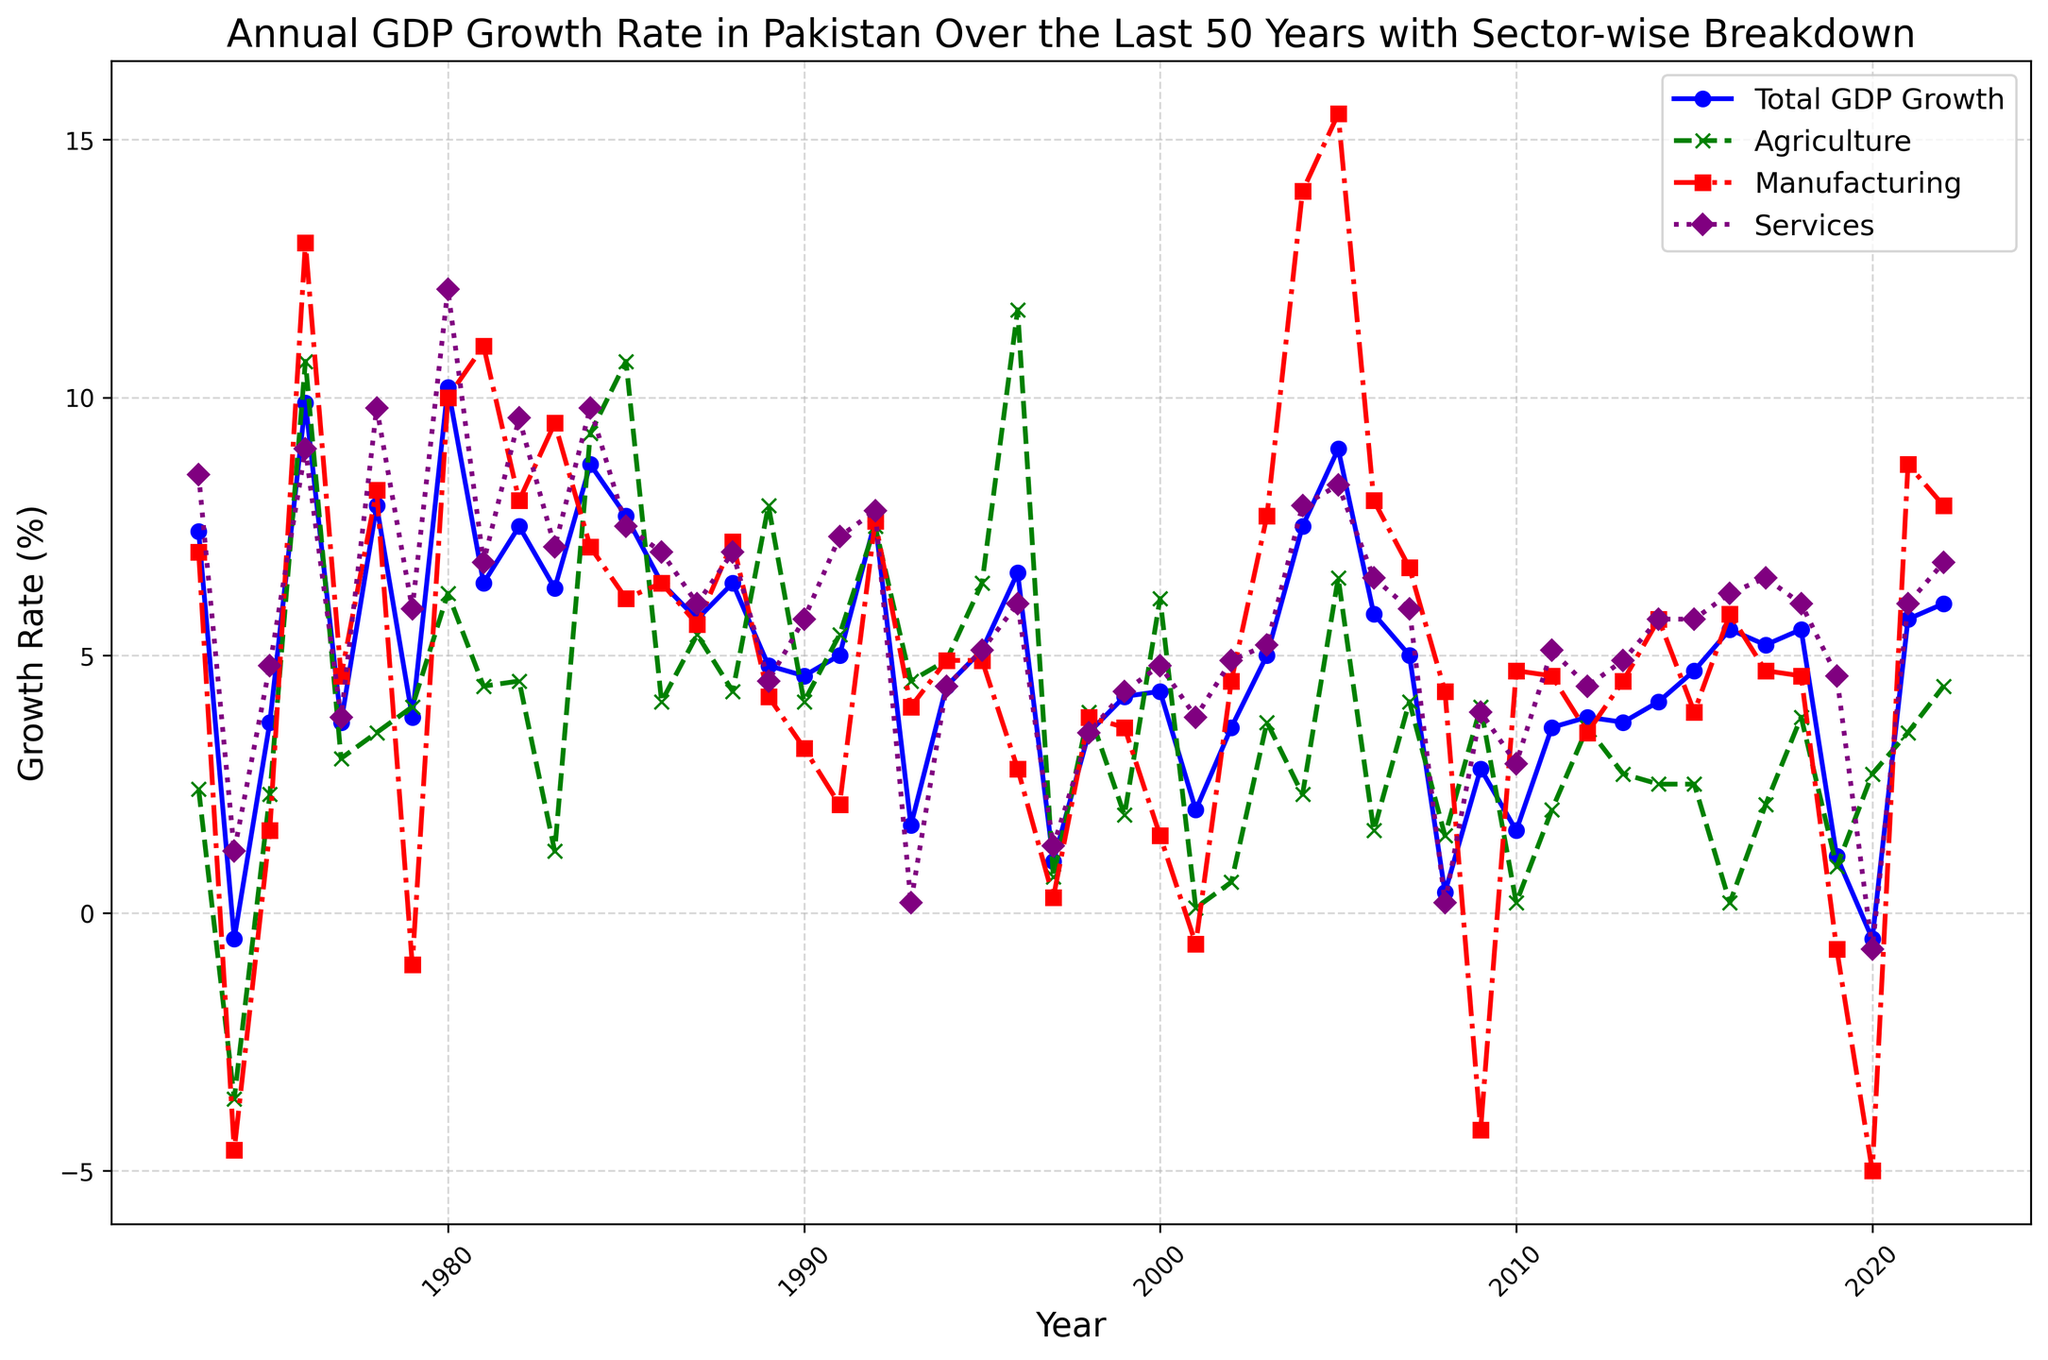How did the Total GDP Growth rate change between the years 1974 and 1975? The Total GDP Growth rate in 1974 was -0.5, and in 1975 it was 3.7. To find the change, subtract the 1974 value from the 1975 value: 3.7 - (-0.5) = 3.7 + 0.5 = 4.2
Answer: 4.2 What year had the highest growth rate in the Manufacturing sector, and what was the rate? By visually inspecting the Manufacturing sector line (red), the peak appears in 2005. The value at this peak is approximately 15.5.
Answer: 2005, 15.5 Compare the GDP growth rates for the Agriculture sector in the years 1984 and 1985. Which year had higher growth, and by how much? In 1984, the Agriculture growth rate was 9.3, and in 1985, it was 10.7. Subtract the 1984 value from the 1985 value: 10.7 - 9.3 = 1.4
Answer: 1985, 1.4 What was the trend in Total GDP Growth from 2018 to 2020? From 2018 (5.5), the Total GDP Growth decreased to 1.1 in 2019 and then further decreased to -0.5 in 2020.
Answer: Decreasing trend Which sector had the lowest growth rate in 2020, and what was the rate? Inspecting the values for 2020, the Manufacturing sector had a growth rate of -5.0, which is the lowest compared to Agriculture (2.7) and Services (-0.7).
Answer: Manufacturing, -5.0 What is the average Total GDP Growth rate between 1990 and 1995? The Total GDP Growth rates from 1990 to 1995 are 4.6, 5.0, 7.6, 1.7, 4.4, and 5.1. Sum these values: 4.6 + 5.0 + 7.6 + 1.7 + 4.4 + 5.1 = 28.4. Divide by the number of values (6): 28.4 / 6 ≈ 4.73
Answer: 4.73 Between which consecutive years did the Services sector experience the highest increase, and by how much? By visually inspecting the Services sector line (purple), the highest increase appears between the years 1979 (5.9) and 1980 (12.1). The difference is 12.1 - 5.9 = 6.2.
Answer: 1979-1980, 6.2 Which sector experienced a negative growth rate in 1979, and what was the rate? By looking at 1979, the only sector with a negative growth rate is Manufacturing (-1.0).
Answer: Manufacturing, -1.0 How did the Agriculture and Manufacturing sectors' growth rates compare in 1996? In 1996, Agriculture had a growth rate of 11.7, and Manufacturing had a growth rate of 2.8. Agriculture was higher by 11.7 - 2.8 = 8.9.
Answer: Agriculture was higher by 8.9 